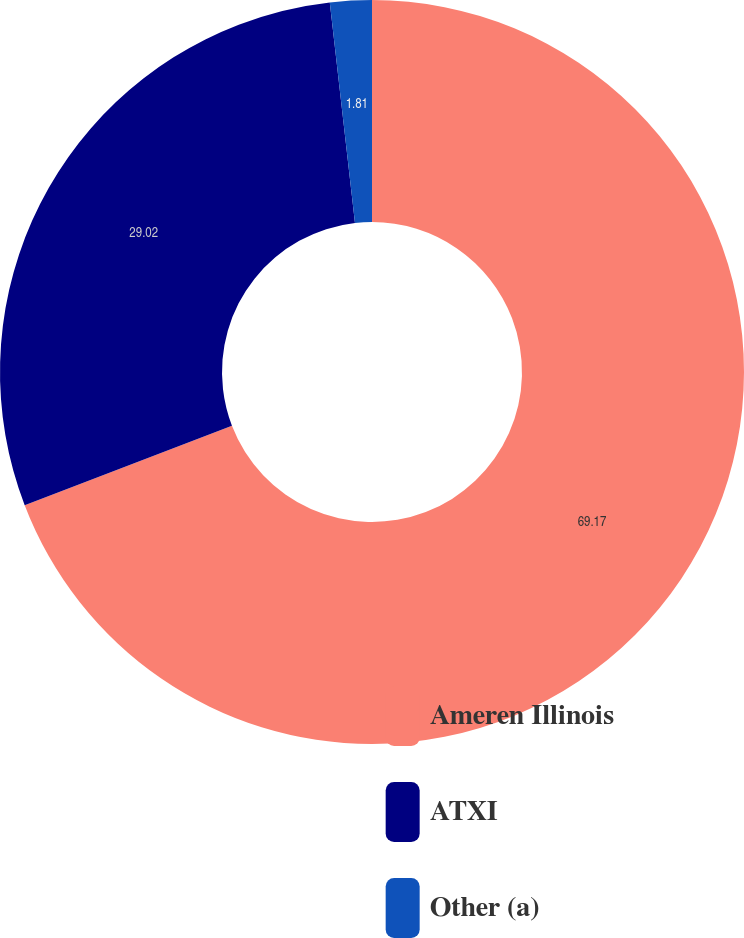Convert chart to OTSL. <chart><loc_0><loc_0><loc_500><loc_500><pie_chart><fcel>Ameren Illinois<fcel>ATXI<fcel>Other (a)<nl><fcel>69.17%<fcel>29.02%<fcel>1.81%<nl></chart> 